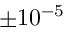<formula> <loc_0><loc_0><loc_500><loc_500>\pm 1 0 ^ { - 5 }</formula> 